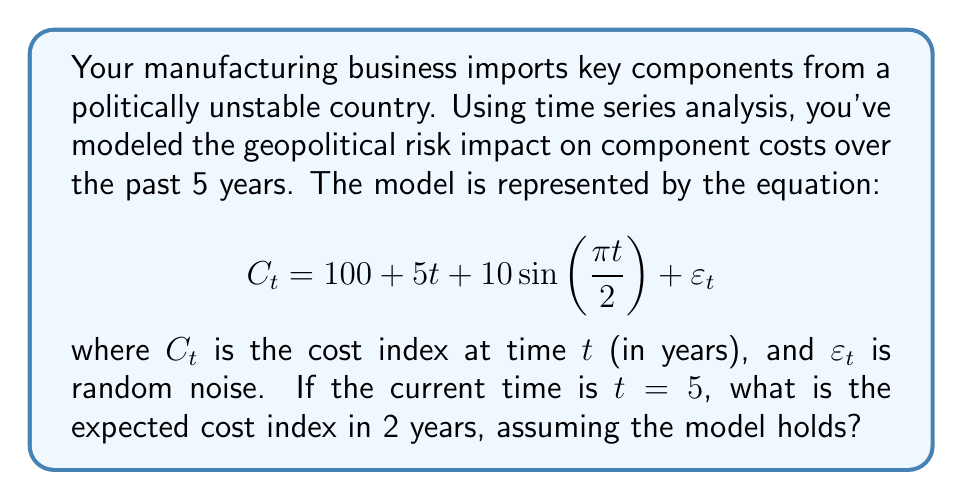Show me your answer to this math problem. To solve this problem, we'll follow these steps:

1) We're given the time series model:
   $$C_t = 100 + 5t + 10\sin(\frac{\pi t}{2}) + \varepsilon_t$$

2) We need to find the expected cost index at $t=7$ (2 years from now, given current time is $t=5$).

3) For the expected value, we can ignore the random noise term $\varepsilon_t$ as its expected value is 0.

4) Let's substitute $t=7$ into the equation:
   $$C_7 = 100 + 5(7) + 10\sin(\frac{\pi (7)}{2})$$

5) Simplify the linear term:
   $$C_7 = 100 + 35 + 10\sin(\frac{7\pi}{2})$$

6) Simplify inside the sine function:
   $$C_7 = 135 + 10\sin(\frac{7\pi}{2})$$

7) Recall that $\sin(\frac{\pi}{2}) = 1$, $\sin(\pi) = 0$, $\sin(\frac{3\pi}{2}) = -1$, $\sin(2\pi) = 0$
   Therefore, $\sin(\frac{7\pi}{2}) = -1$

8) Substitute this value:
   $$C_7 = 135 + 10(-1) = 135 - 10 = 125$$

Therefore, the expected cost index in 2 years is 125.
Answer: 125 